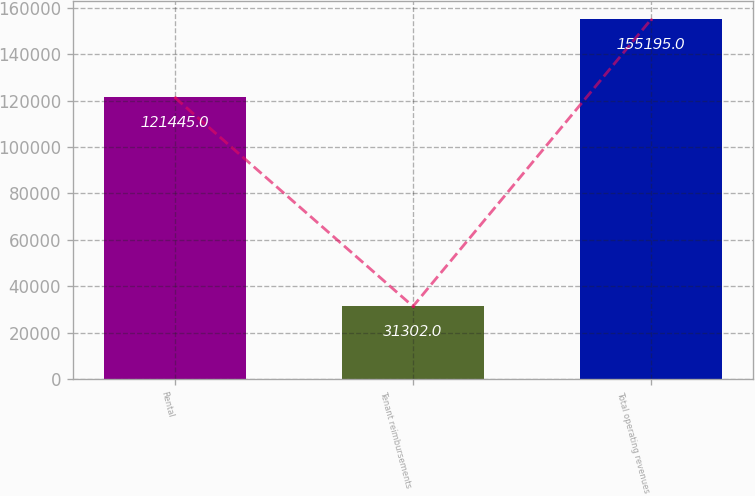<chart> <loc_0><loc_0><loc_500><loc_500><bar_chart><fcel>Rental<fcel>Tenant reimbursements<fcel>Total operating revenues<nl><fcel>121445<fcel>31302<fcel>155195<nl></chart> 